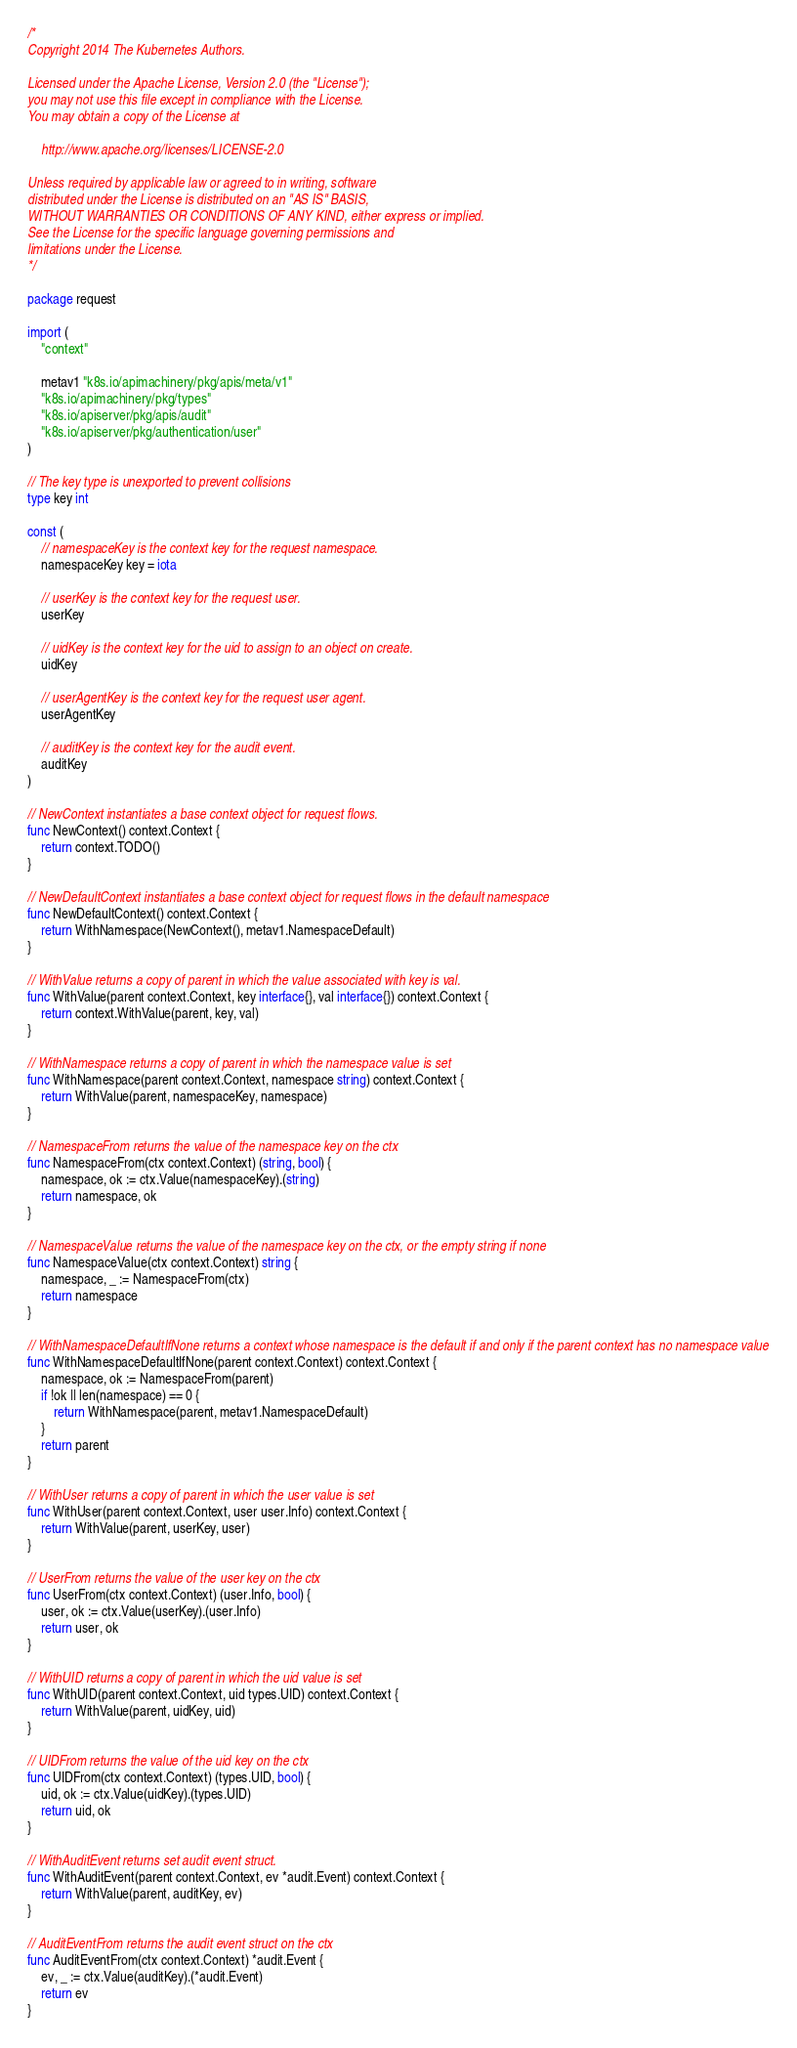Convert code to text. <code><loc_0><loc_0><loc_500><loc_500><_Go_>/*
Copyright 2014 The Kubernetes Authors.

Licensed under the Apache License, Version 2.0 (the "License");
you may not use this file except in compliance with the License.
You may obtain a copy of the License at

    http://www.apache.org/licenses/LICENSE-2.0

Unless required by applicable law or agreed to in writing, software
distributed under the License is distributed on an "AS IS" BASIS,
WITHOUT WARRANTIES OR CONDITIONS OF ANY KIND, either express or implied.
See the License for the specific language governing permissions and
limitations under the License.
*/

package request

import (
	"context"

	metav1 "k8s.io/apimachinery/pkg/apis/meta/v1"
	"k8s.io/apimachinery/pkg/types"
	"k8s.io/apiserver/pkg/apis/audit"
	"k8s.io/apiserver/pkg/authentication/user"
)

// The key type is unexported to prevent collisions
type key int

const (
	// namespaceKey is the context key for the request namespace.
	namespaceKey key = iota

	// userKey is the context key for the request user.
	userKey

	// uidKey is the context key for the uid to assign to an object on create.
	uidKey

	// userAgentKey is the context key for the request user agent.
	userAgentKey

	// auditKey is the context key for the audit event.
	auditKey
)

// NewContext instantiates a base context object for request flows.
func NewContext() context.Context {
	return context.TODO()
}

// NewDefaultContext instantiates a base context object for request flows in the default namespace
func NewDefaultContext() context.Context {
	return WithNamespace(NewContext(), metav1.NamespaceDefault)
}

// WithValue returns a copy of parent in which the value associated with key is val.
func WithValue(parent context.Context, key interface{}, val interface{}) context.Context {
	return context.WithValue(parent, key, val)
}

// WithNamespace returns a copy of parent in which the namespace value is set
func WithNamespace(parent context.Context, namespace string) context.Context {
	return WithValue(parent, namespaceKey, namespace)
}

// NamespaceFrom returns the value of the namespace key on the ctx
func NamespaceFrom(ctx context.Context) (string, bool) {
	namespace, ok := ctx.Value(namespaceKey).(string)
	return namespace, ok
}

// NamespaceValue returns the value of the namespace key on the ctx, or the empty string if none
func NamespaceValue(ctx context.Context) string {
	namespace, _ := NamespaceFrom(ctx)
	return namespace
}

// WithNamespaceDefaultIfNone returns a context whose namespace is the default if and only if the parent context has no namespace value
func WithNamespaceDefaultIfNone(parent context.Context) context.Context {
	namespace, ok := NamespaceFrom(parent)
	if !ok || len(namespace) == 0 {
		return WithNamespace(parent, metav1.NamespaceDefault)
	}
	return parent
}

// WithUser returns a copy of parent in which the user value is set
func WithUser(parent context.Context, user user.Info) context.Context {
	return WithValue(parent, userKey, user)
}

// UserFrom returns the value of the user key on the ctx
func UserFrom(ctx context.Context) (user.Info, bool) {
	user, ok := ctx.Value(userKey).(user.Info)
	return user, ok
}

// WithUID returns a copy of parent in which the uid value is set
func WithUID(parent context.Context, uid types.UID) context.Context {
	return WithValue(parent, uidKey, uid)
}

// UIDFrom returns the value of the uid key on the ctx
func UIDFrom(ctx context.Context) (types.UID, bool) {
	uid, ok := ctx.Value(uidKey).(types.UID)
	return uid, ok
}

// WithAuditEvent returns set audit event struct.
func WithAuditEvent(parent context.Context, ev *audit.Event) context.Context {
	return WithValue(parent, auditKey, ev)
}

// AuditEventFrom returns the audit event struct on the ctx
func AuditEventFrom(ctx context.Context) *audit.Event {
	ev, _ := ctx.Value(auditKey).(*audit.Event)
	return ev
}
</code> 